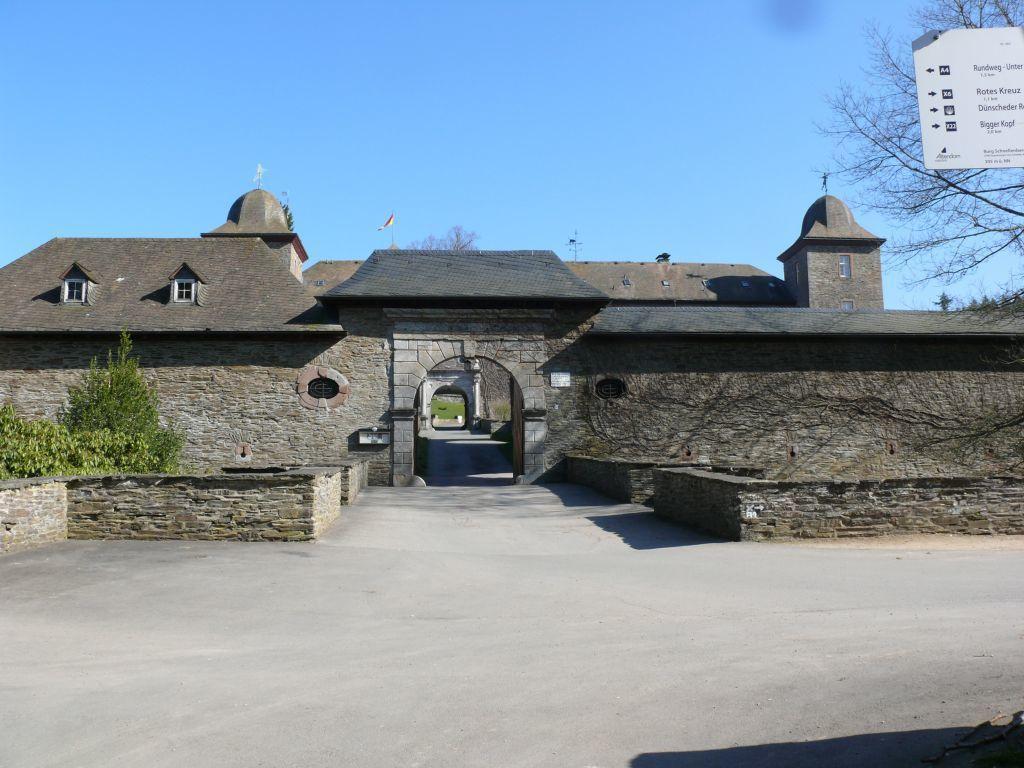Can you describe this image briefly? At the bottom of the picture, we see the road. On either side of the picture, we see the trees and the walls, which are made up of cobblestones. In the middle, we see an arch and a building which is made up of cobblestones. In the background, we see the trees, pole and a flag. At the top, we see the sky, which is blue in color. In the right top, we see a board in white color with some text written on it. Behind that, we see the trees. 